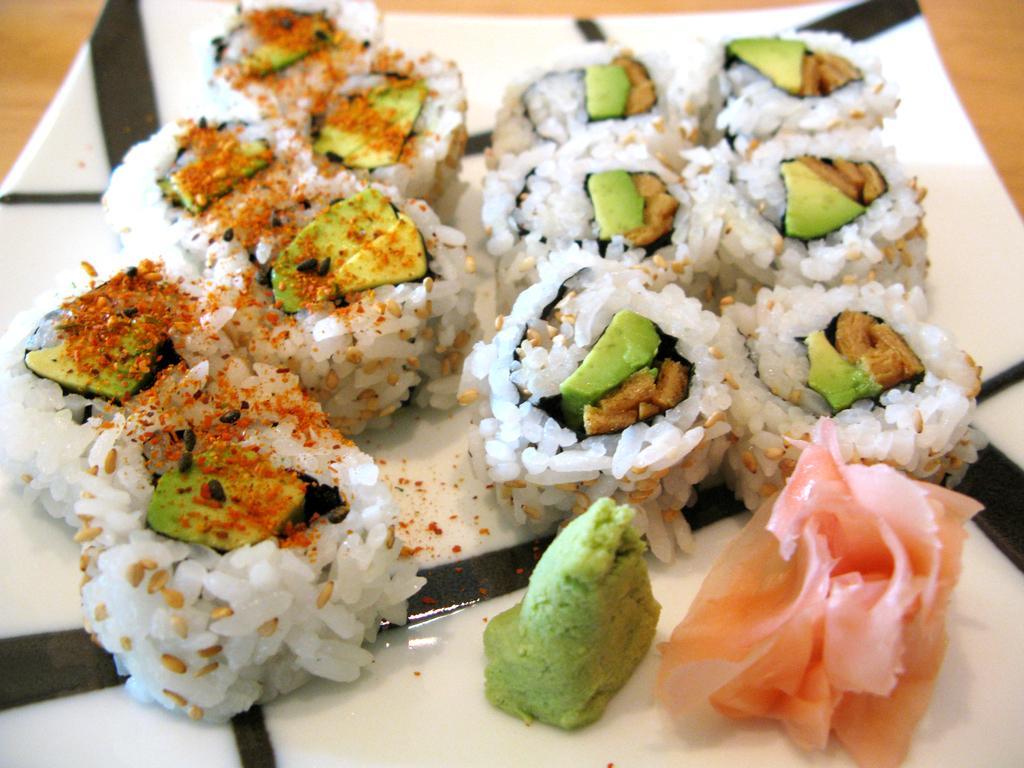How would you summarize this image in a sentence or two? In this picture we can see a plate on the wooden surface with food items on it. 